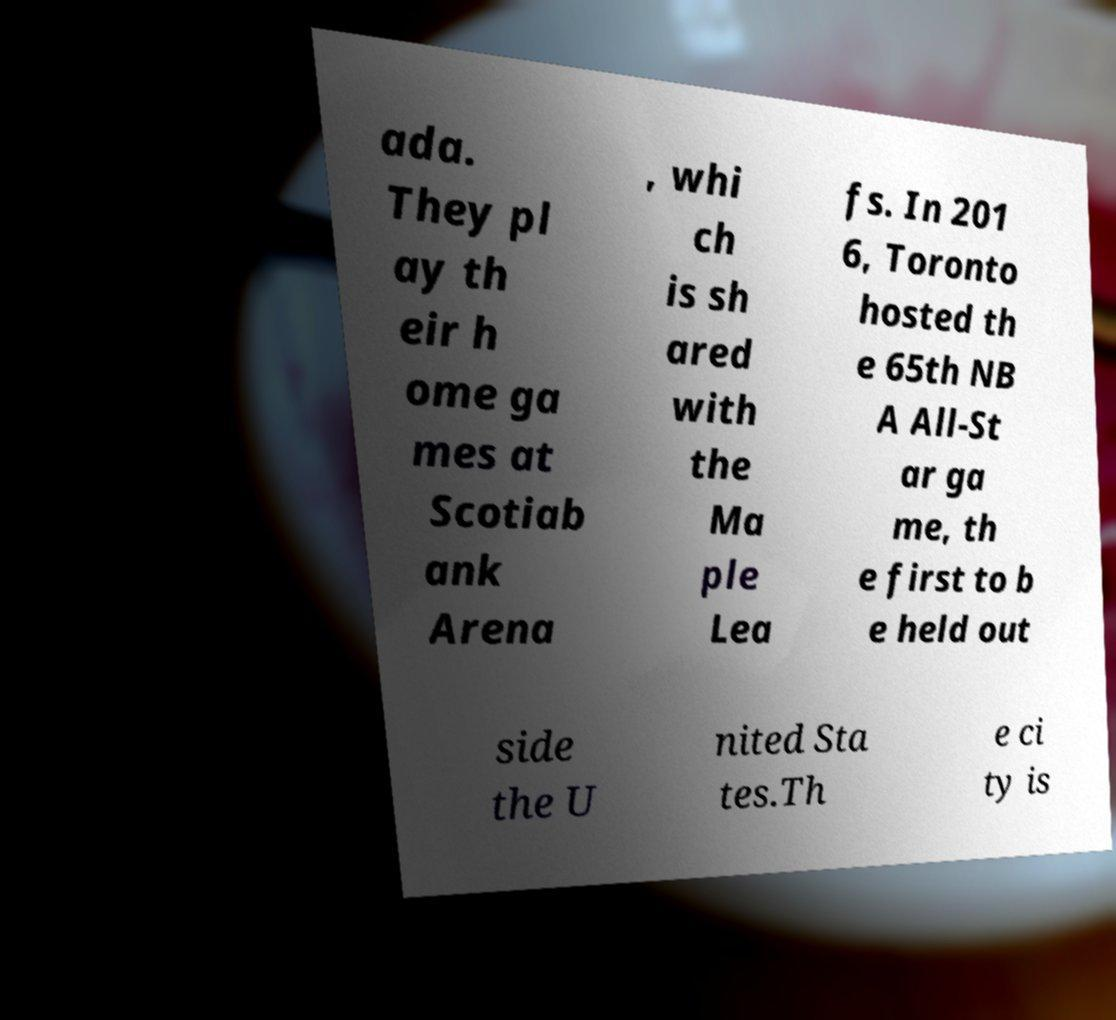What messages or text are displayed in this image? I need them in a readable, typed format. ada. They pl ay th eir h ome ga mes at Scotiab ank Arena , whi ch is sh ared with the Ma ple Lea fs. In 201 6, Toronto hosted th e 65th NB A All-St ar ga me, th e first to b e held out side the U nited Sta tes.Th e ci ty is 